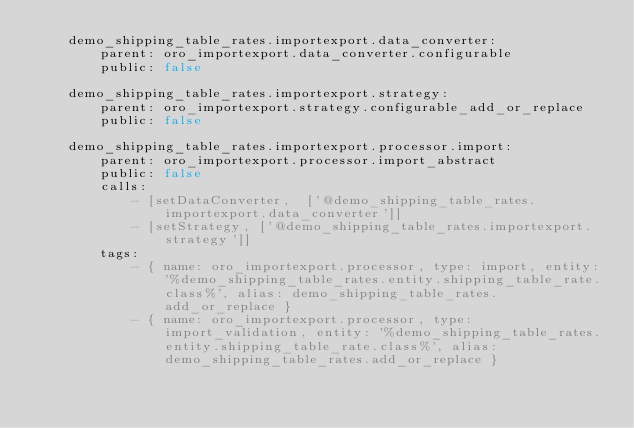Convert code to text. <code><loc_0><loc_0><loc_500><loc_500><_YAML_>    demo_shipping_table_rates.importexport.data_converter:
        parent: oro_importexport.data_converter.configurable
        public: false

    demo_shipping_table_rates.importexport.strategy:
        parent: oro_importexport.strategy.configurable_add_or_replace
        public: false

    demo_shipping_table_rates.importexport.processor.import:
        parent: oro_importexport.processor.import_abstract
        public: false
        calls:
            - [setDataConverter,  ['@demo_shipping_table_rates.importexport.data_converter']]
            - [setStrategy, ['@demo_shipping_table_rates.importexport.strategy']]
        tags:
            - { name: oro_importexport.processor, type: import, entity: '%demo_shipping_table_rates.entity.shipping_table_rate.class%', alias: demo_shipping_table_rates.add_or_replace }
            - { name: oro_importexport.processor, type: import_validation, entity: '%demo_shipping_table_rates.entity.shipping_table_rate.class%', alias: demo_shipping_table_rates.add_or_replace }
</code> 